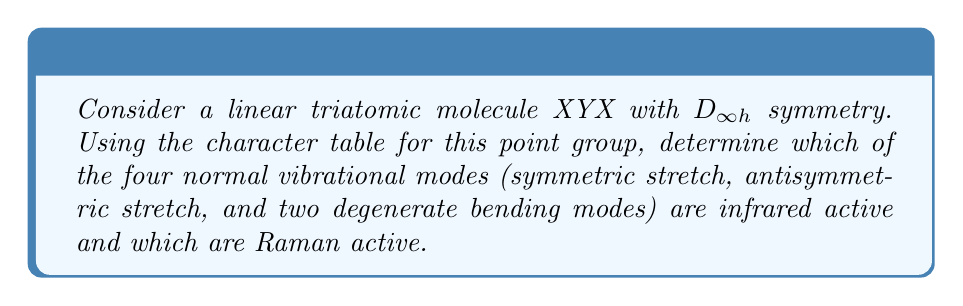Show me your answer to this math problem. Let's approach this step-by-step:

1. First, recall that for a vibration to be infrared (IR) active, it must transform as the same irreducible representation as one or more components of the dipole moment (x, y, or z). In the $D_{\infty h}$ point group, these transform as $\Sigma_u^+$ (z) and $\Pi_u$ (x, y).

2. For Raman activity, the vibration must transform as the same irreducible representation as one or more components of the polarizability tensor ($x^2$, $y^2$, $z^2$, xy, xz, yz). These transform as $\Sigma_g^+$ ($x^2+y^2$, $z^2$) and $\Pi_g$ (xz, yz) in the $D_{\infty h}$ point group.

3. Now, let's consider each vibrational mode:

   a) Symmetric stretch: This mode preserves the molecule's symmetry and transforms as $\Sigma_g^+$.
   b) Antisymmetric stretch: This mode changes sign under inversion and transforms as $\Sigma_u^+$.
   c) Bending modes: These are degenerate and transform as $\Pi_u$.

4. Comparing with our IR and Raman activity criteria:

   a) Symmetric stretch ($\Sigma_g^+$): 
      - Not IR active (doesn't match $\Sigma_u^+$ or $\Pi_u$)
      - Raman active (matches $\Sigma_g^+$)

   b) Antisymmetric stretch ($\Sigma_u^+$):
      - IR active (matches $\Sigma_u^+$)
      - Not Raman active (doesn't match $\Sigma_g^+$ or $\Pi_g$)

   c) Bending modes ($\Pi_u$):
      - IR active (matches $\Pi_u$)
      - Not Raman active (doesn't match $\Sigma_g^+$ or $\Pi_g$)
Answer: Symmetric stretch: Raman active only; Antisymmetric stretch: IR active only; Bending modes: IR active only 